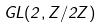Convert formula to latex. <formula><loc_0><loc_0><loc_500><loc_500>G L ( 2 , Z / 2 Z )</formula> 